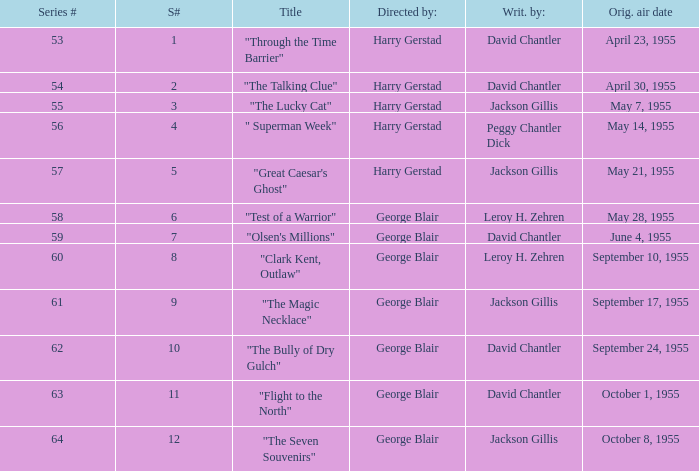Who directed the episode that was written by Jackson Gillis and Originally aired on May 21, 1955? Harry Gerstad. 